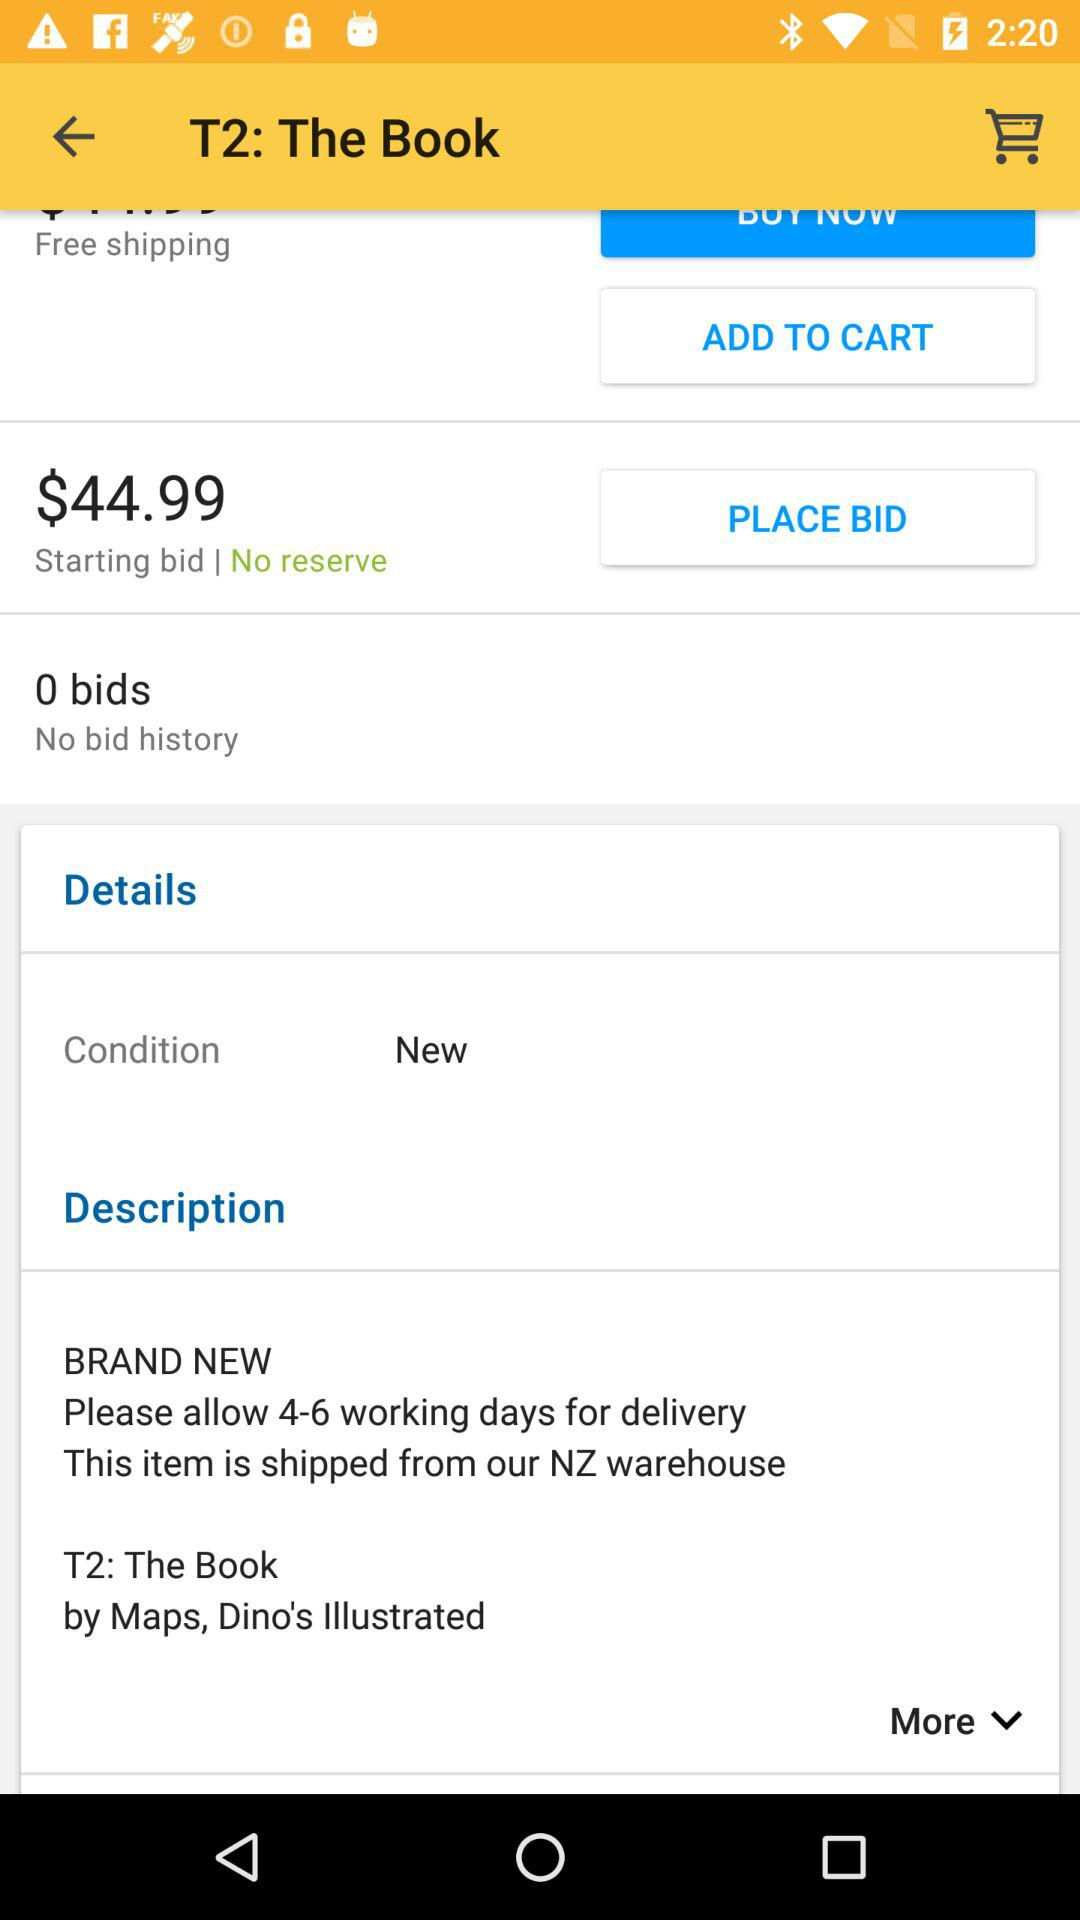From where will the item be shipped? The item will be shipped from NZ warehouse. 